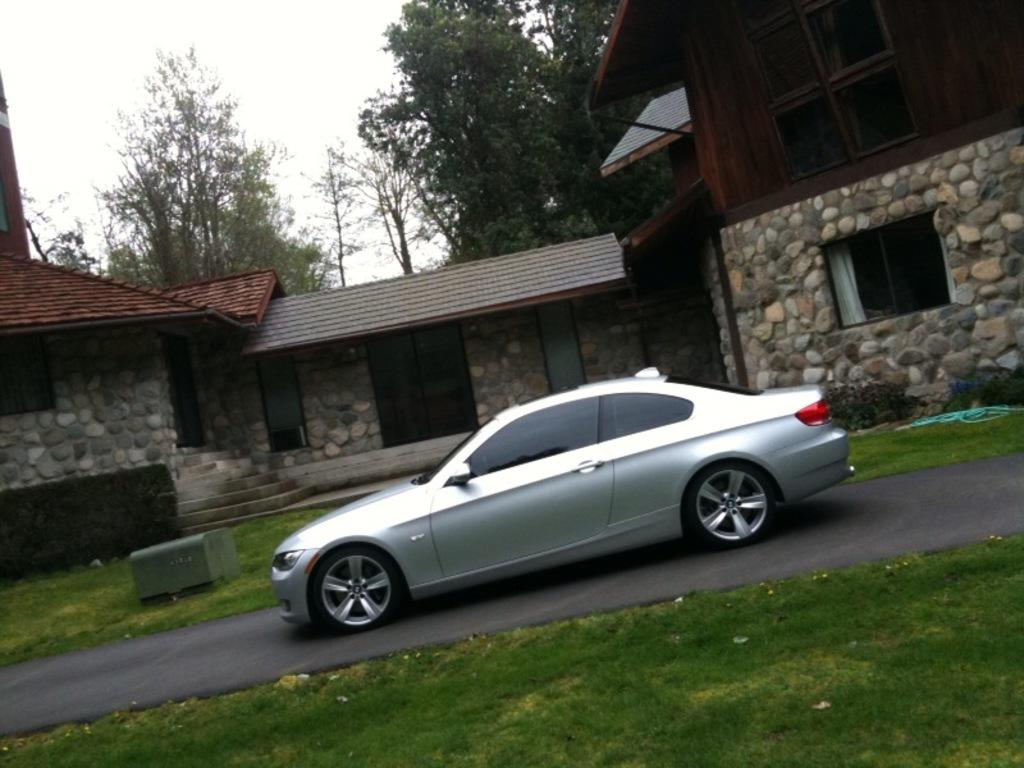What is the main subject of the image? The main subject of the image is a car on the road. What structures are located beside the car in the image? There are houses beside the car in the image. What type of vegetation can be seen in the image? There are trees in the image. What type of ground cover is present in the image? There is grass in the image. How many seeds are visible in the image? There are no seeds present in the image. What day of the week is it in the image? The day of the week is not visible or mentioned in the image. What type of sound can be heard coming from the car in the image? The image is silent, and therefore no sound can be heard. 